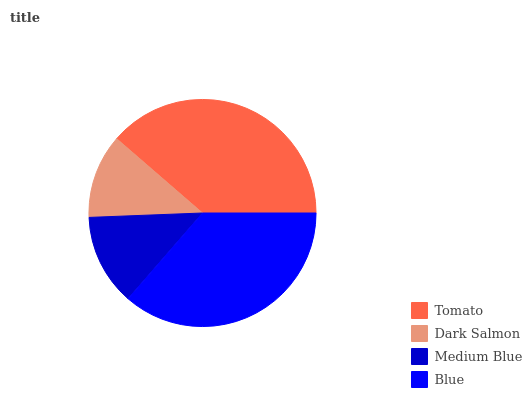Is Dark Salmon the minimum?
Answer yes or no. Yes. Is Tomato the maximum?
Answer yes or no. Yes. Is Medium Blue the minimum?
Answer yes or no. No. Is Medium Blue the maximum?
Answer yes or no. No. Is Medium Blue greater than Dark Salmon?
Answer yes or no. Yes. Is Dark Salmon less than Medium Blue?
Answer yes or no. Yes. Is Dark Salmon greater than Medium Blue?
Answer yes or no. No. Is Medium Blue less than Dark Salmon?
Answer yes or no. No. Is Blue the high median?
Answer yes or no. Yes. Is Medium Blue the low median?
Answer yes or no. Yes. Is Dark Salmon the high median?
Answer yes or no. No. Is Dark Salmon the low median?
Answer yes or no. No. 